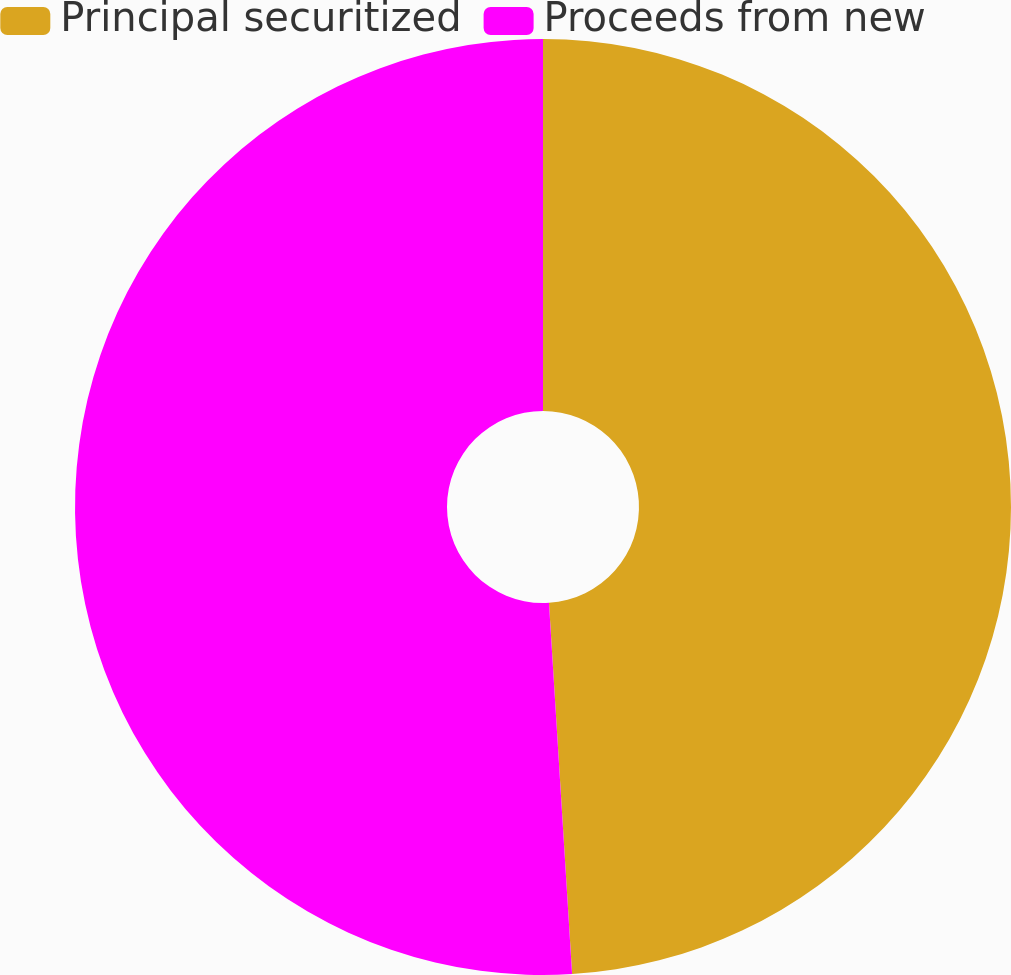<chart> <loc_0><loc_0><loc_500><loc_500><pie_chart><fcel>Principal securitized<fcel>Proceeds from new<nl><fcel>49.01%<fcel>50.99%<nl></chart> 